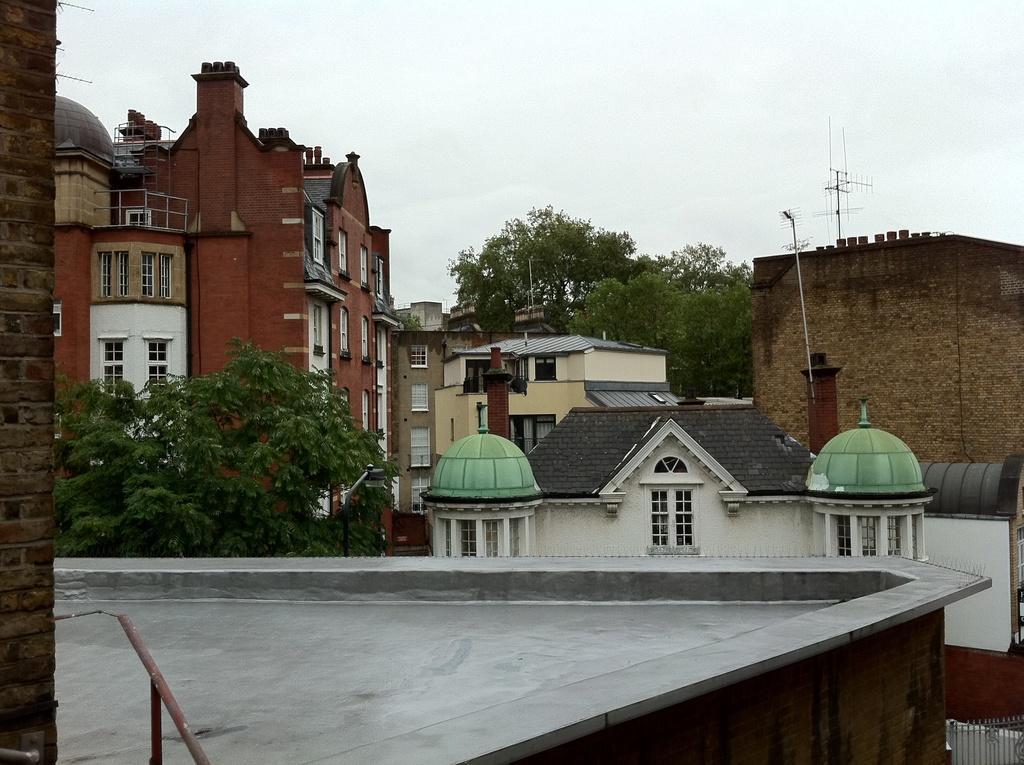Could you give a brief overview of what you see in this image? In this image there are buildings, trees, windows, rods, cloudy sky, railing and objects.   